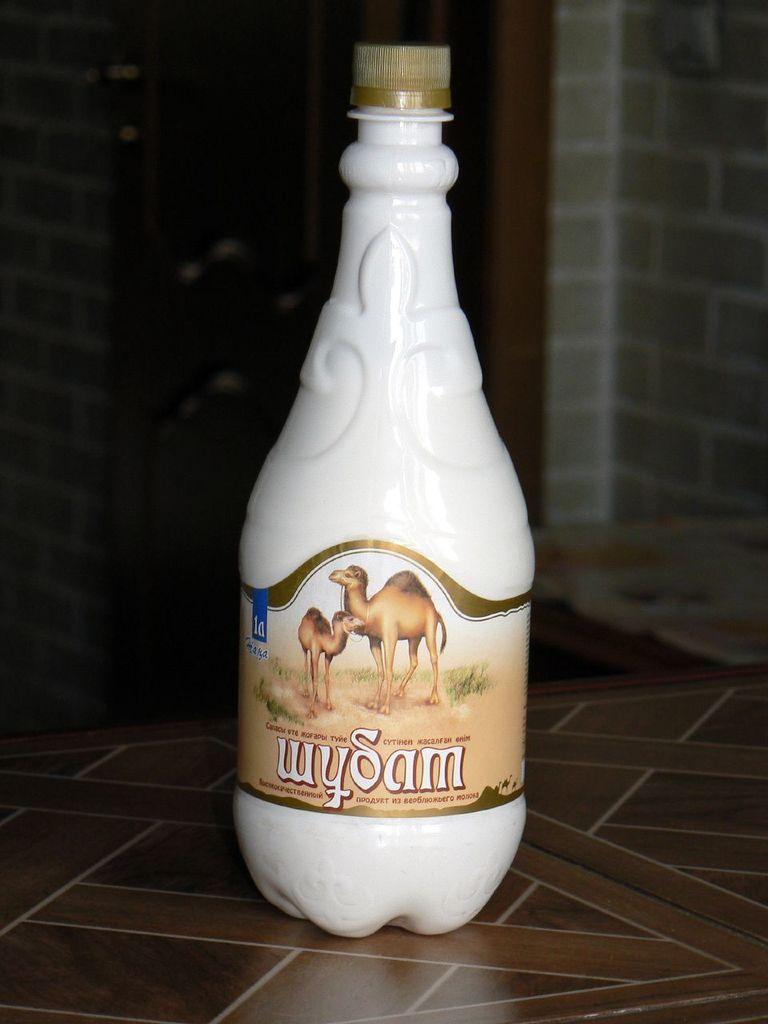What is the name of this turkish drink?
Ensure brevity in your answer.  Wysam. What animal is on the bottle?
Make the answer very short. Answering does not require reading text in the image. 